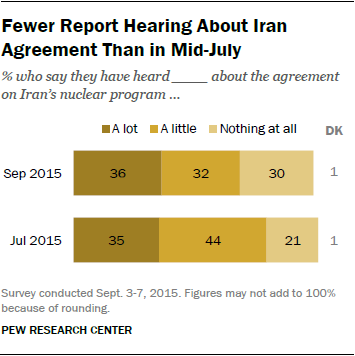Highlight a few significant elements in this photo. The opinion with the smallest change between two times is DK. In September 2015, 36% of people chose to participate in a lot. 